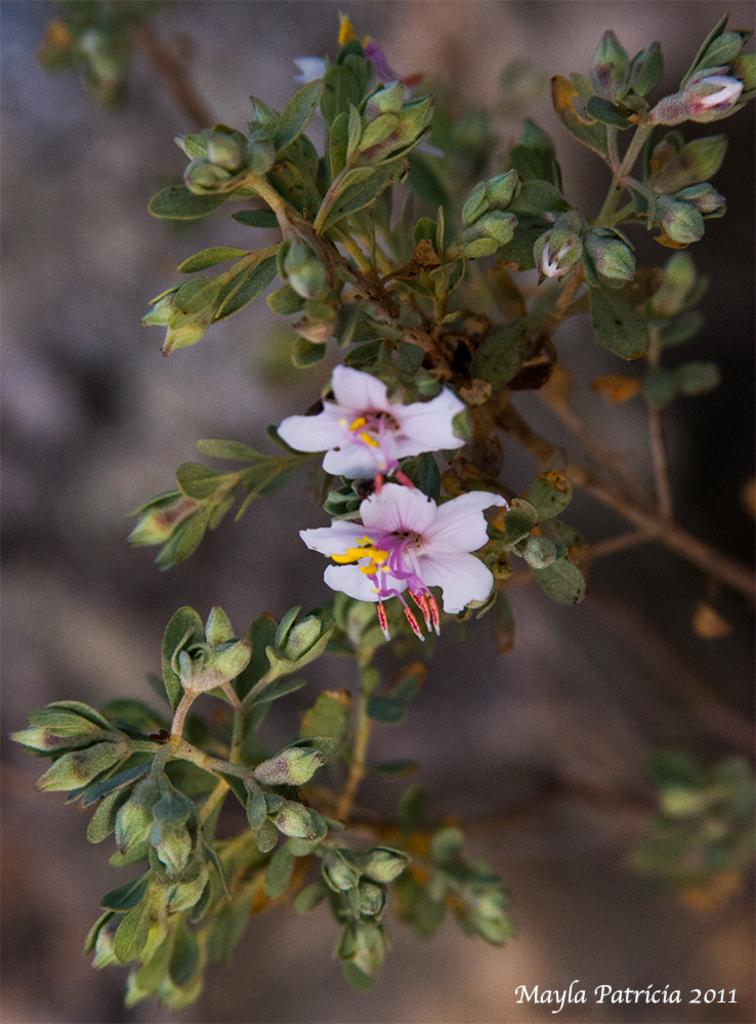What type of flowers can be seen on the plant in the image? There are white flowers on the plant in the image. What is the growth stage of the flowers on the plant? There are buds on the plant, indicating that some flowers are still in the process of blooming. What can be observed in the background of the image? There is a blurred image in the background. Is there any additional information or branding present in the image? Yes, there is a watermark in the bottom right corner of the image. How many chickens are visible in the image? There are no chickens present in the image. What mode of transport is being used by the flowers in the image? The flowers are stationary on the plant and are not using any mode of transport. 